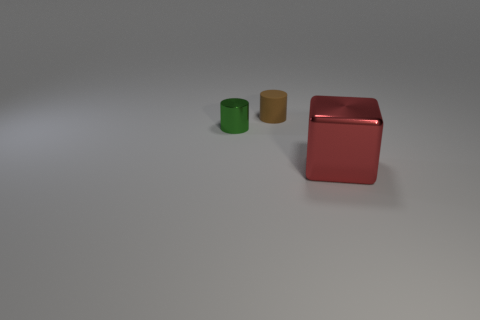Are there any indications of the scale or size of the objects relative to a common object? There are no clear indications of scale in the image because familiar reference objects are absent. This makes it difficult to determine the actual size of the objects. However, comparing the three items to each other suggests a size hierarchy from smallest to largest. 